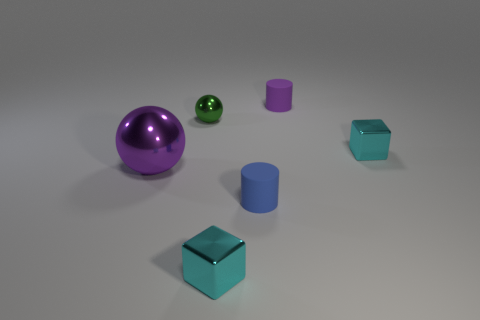What might be the material of the objects? While it's difficult to determine the exact material from a picture, given their sleek appearance and reflections, the objects might be made of polished metal or plastic. 